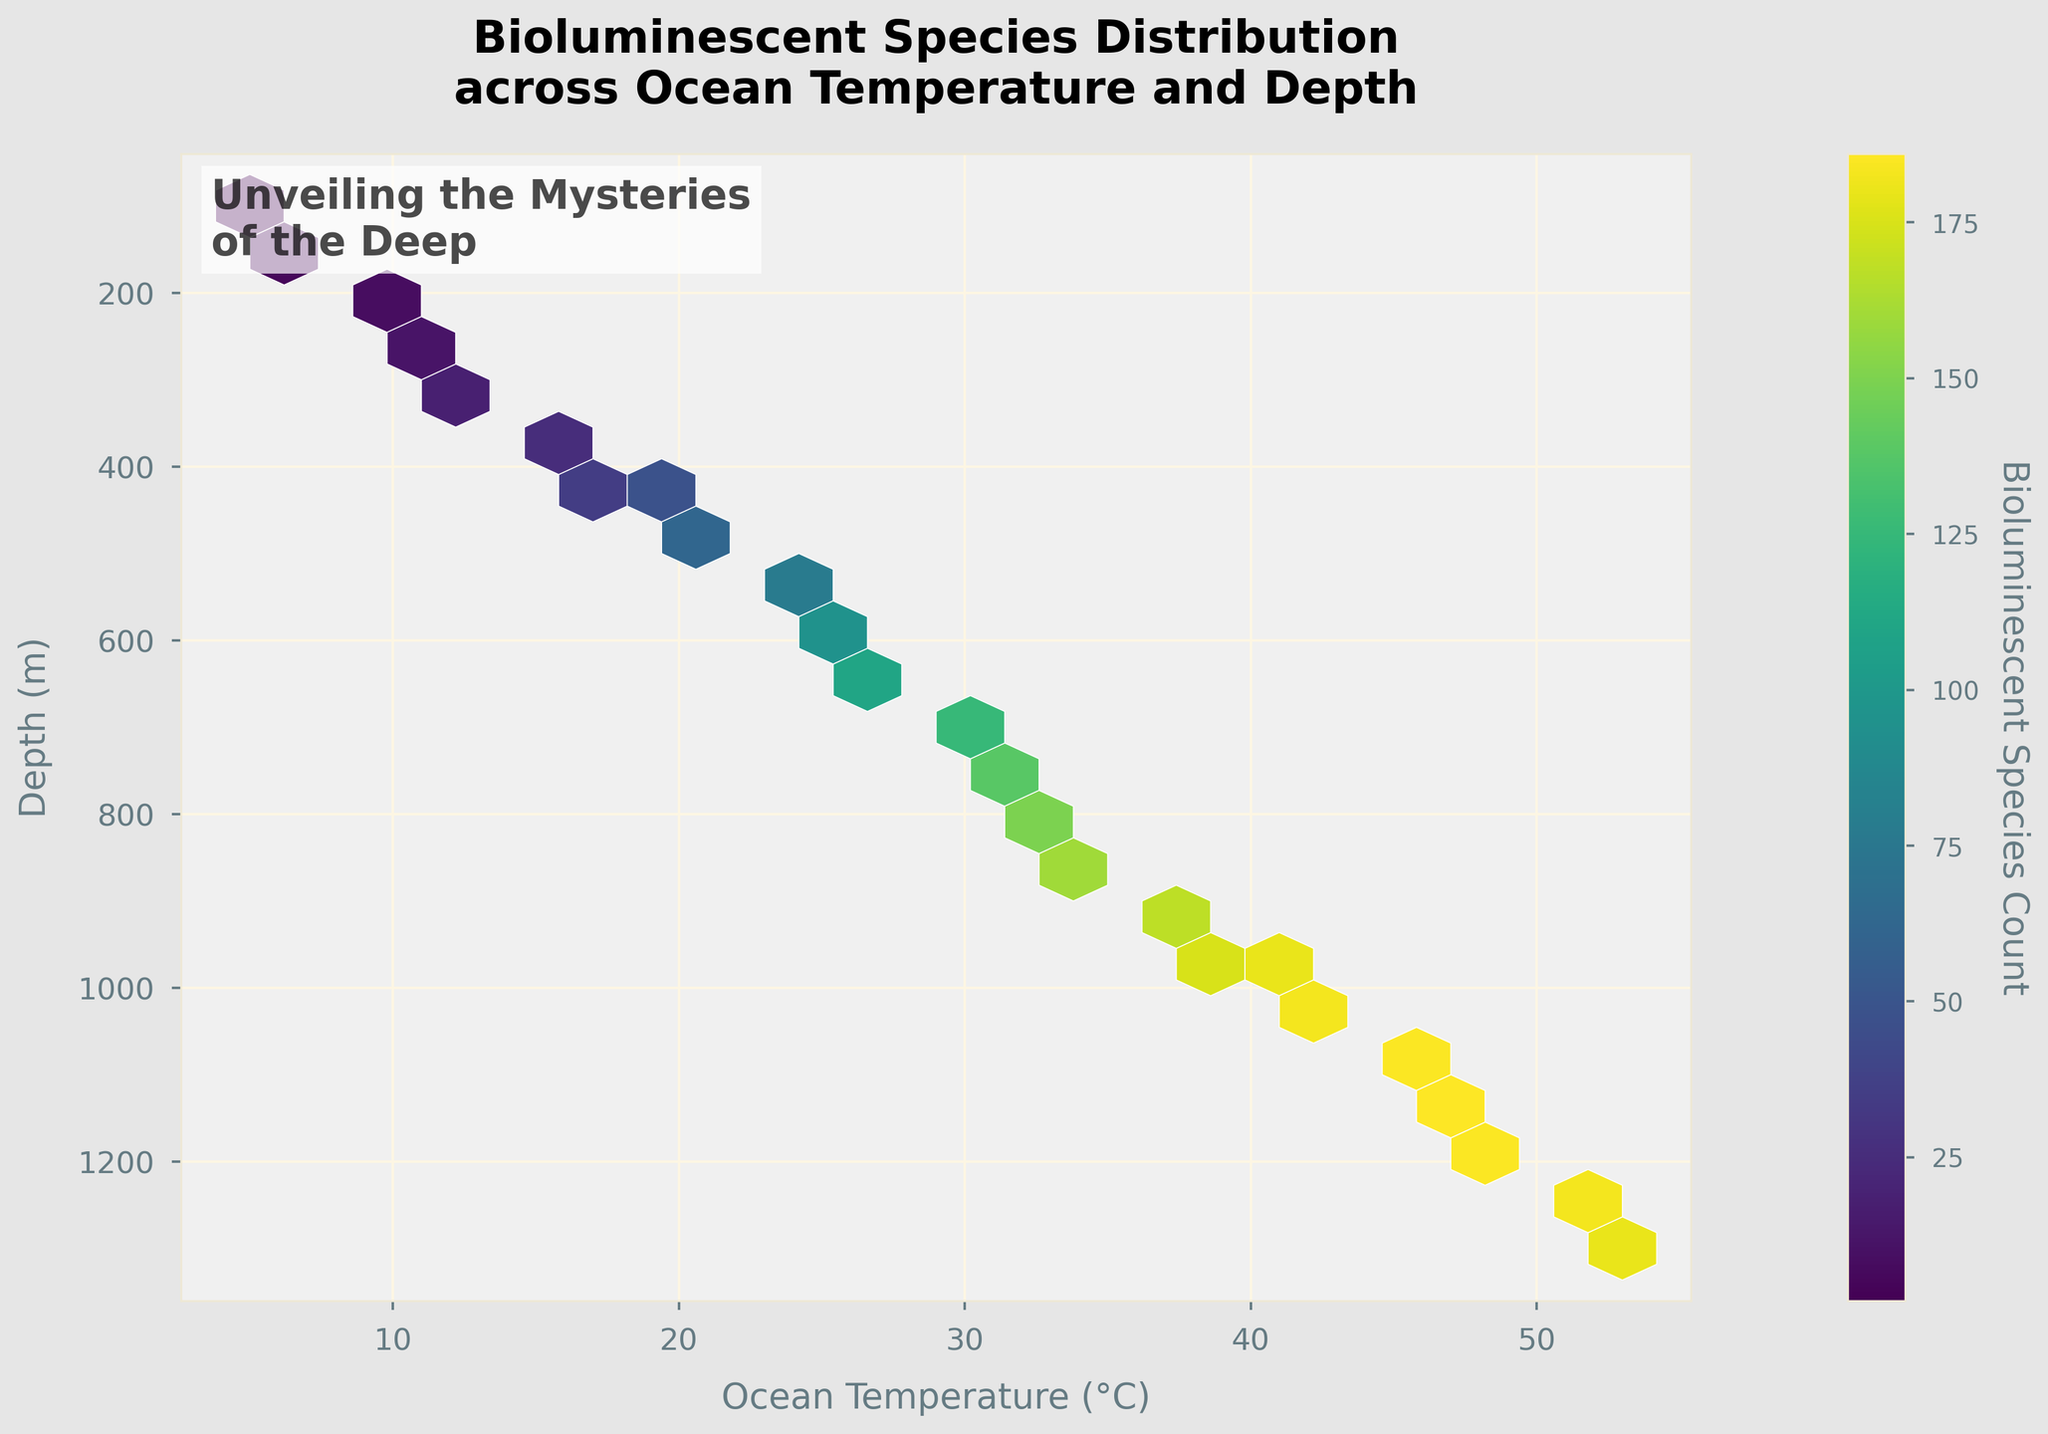What is the title of the figure? The title is usually located at the top of the plot and it summarizes the main focus of the visualization.
Answer: Bioluminescent Species Distribution across Ocean Temperature and Depth What is the range of ocean temperatures shown in the plot? You can look at the x-axis, which represents the Ocean Temperature, and note the minimum and maximum values.
Answer: 5°C to 53°C How is the depth represented in the plot? The y-axis represents depth, and it typically includes a label and values indicating the measurement. In this plot, the y-axis label is "Depth (m)" and values range from shallow to deep water.
Answer: Depth is represented by the y-axis, ranging from 100m to 1300m What color map is used in the hexbin plot, and what does it represent? The color map, visible in the hexagon bins, varies from one color to another and represents the count of bioluminescent species.
Answer: Viridis, indicating Bioluminescent Species Count At what temperature and depth is the highest count of bioluminescent species found? Identify the darkest or most saturated hexagon bin, and cross-reference its position with the x-axis and y-axis.
Answer: Around 53°C and 1300m How does the bioluminescent species count change as depth increases at a consistent temperature of 25°C? Observe hexagon bins located approximately at 25°C along varying depths, noting changes in color intensity as depth increases.
Answer: The count generally increases with depth What general trend can you observe about the relationship between ocean temperature and bioluminescent species count? Look for patterns in color intensity across the temperature spectrum in the plot to establish a trend.
Answer: The count increases with both temperature and depth Which range of ocean temperatures appears to have the most bioluminescent species? Compare the general color intensity across segments of the temperature range on the x-axis.
Answer: 25°C to 53°C Are there any specific depths where bioluminescent species counts appear to be consistently high across various temperatures? Identify any depth range in the y-axis where the color intensity remains high regardless of temperature.
Answer: Deeper regions (900m to 1300m) show consistently high counts What can you imply about ocean temperature and depth zones with very low bioluminescent species count? Check for the lightest colored or least saturated hexagon bins across the plot and note their temperature and depth positions.
Answer: Shallower waters and lower temperatures, below 300m and 15°C 